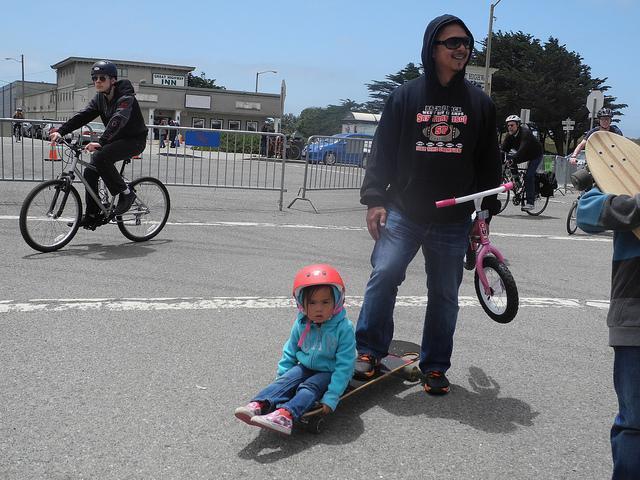How many people are there?
Give a very brief answer. 5. How many skateboards are there?
Give a very brief answer. 2. How many bicycles are visible?
Give a very brief answer. 2. 